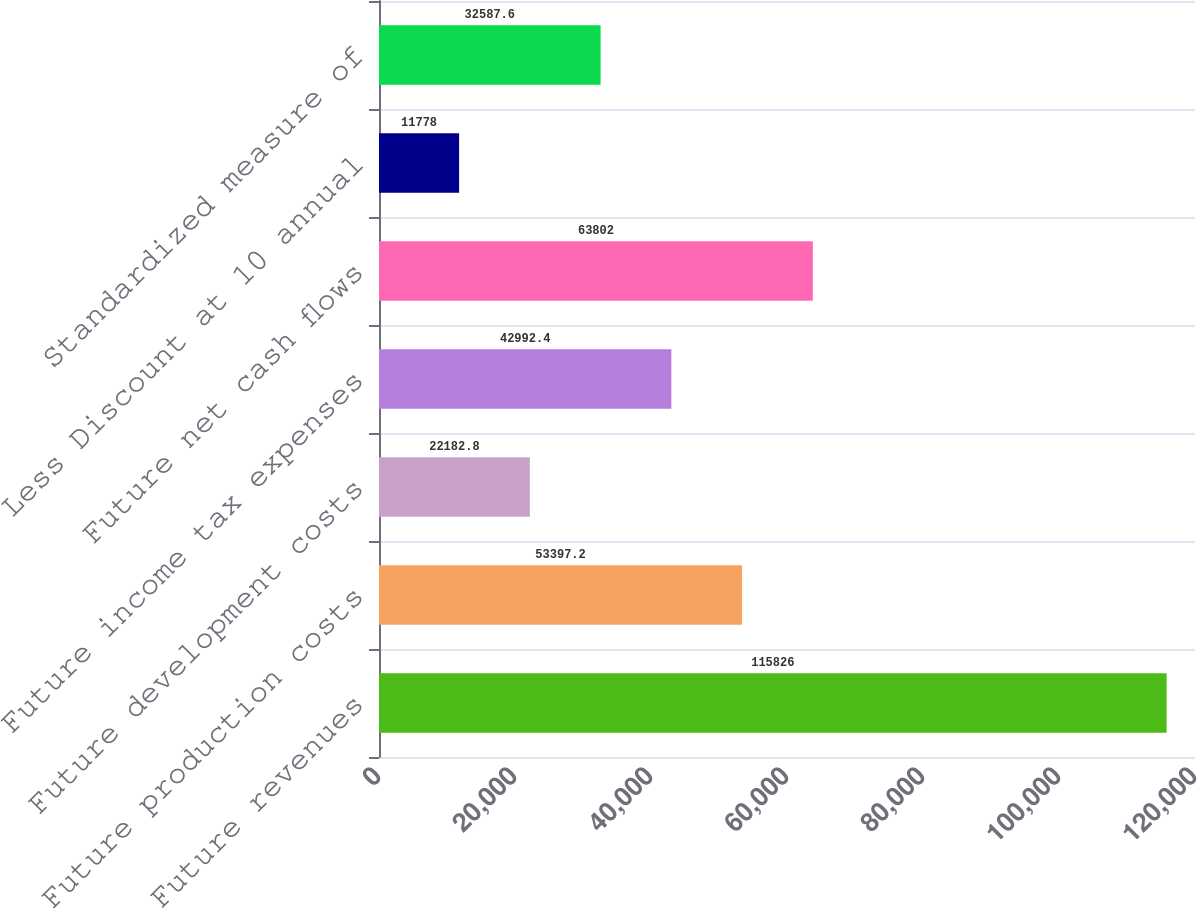<chart> <loc_0><loc_0><loc_500><loc_500><bar_chart><fcel>Future revenues<fcel>Future production costs<fcel>Future development costs<fcel>Future income tax expenses<fcel>Future net cash flows<fcel>Less Discount at 10 annual<fcel>Standardized measure of<nl><fcel>115826<fcel>53397.2<fcel>22182.8<fcel>42992.4<fcel>63802<fcel>11778<fcel>32587.6<nl></chart> 